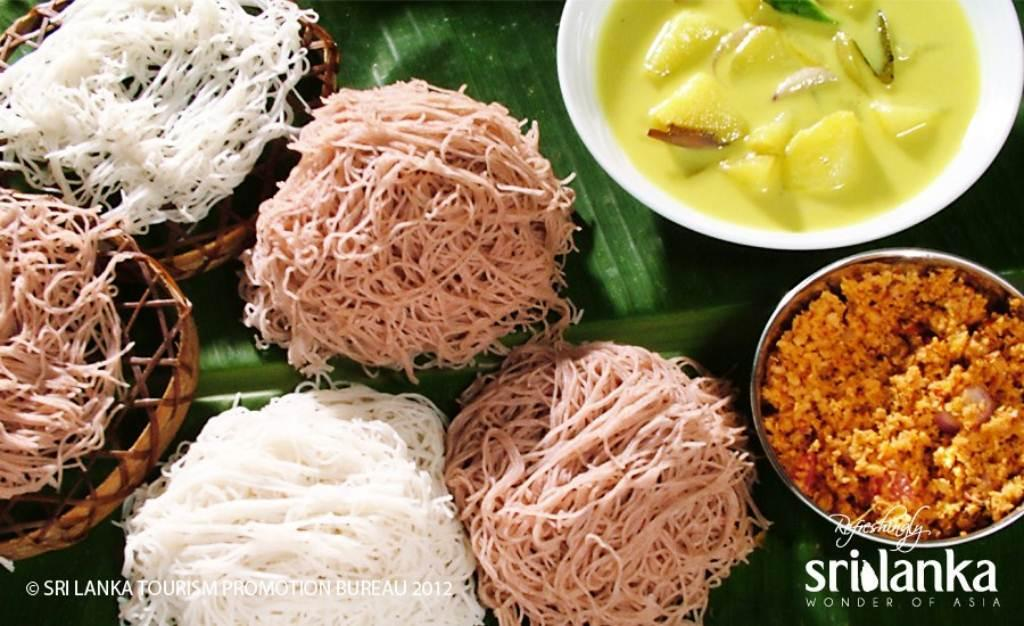What type of containers are present in the image? There are bowls in the image. What is inside the containers? There are food items in the image. What material are some of the objects made of? There are wooden objects in the image. On what surface are the items placed? The items are placed on a leaf. What can be seen at the bottom of the image? There is text visible at the bottom of the image. What type of wine is being served in the image? There is no wine present in the image; it features bowls with food items placed on a leaf. How much profit can be made from the food items in the image? The image does not provide any information about profit or the value of the food items, so it cannot be determined. 